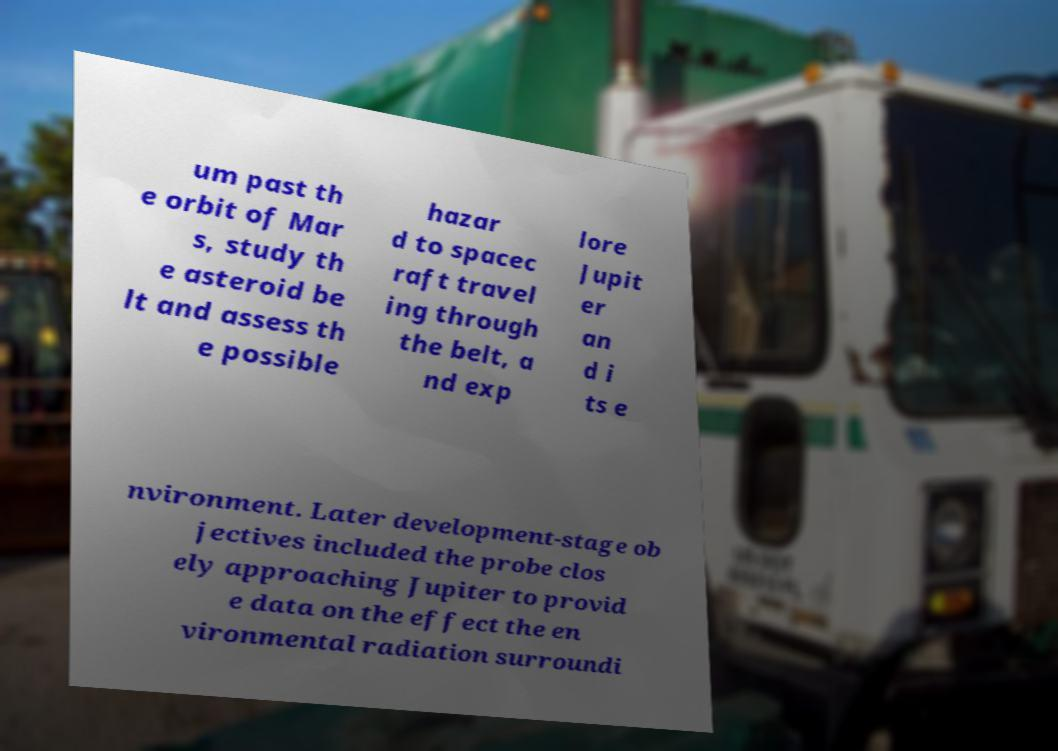Could you assist in decoding the text presented in this image and type it out clearly? um past th e orbit of Mar s, study th e asteroid be lt and assess th e possible hazar d to spacec raft travel ing through the belt, a nd exp lore Jupit er an d i ts e nvironment. Later development-stage ob jectives included the probe clos ely approaching Jupiter to provid e data on the effect the en vironmental radiation surroundi 